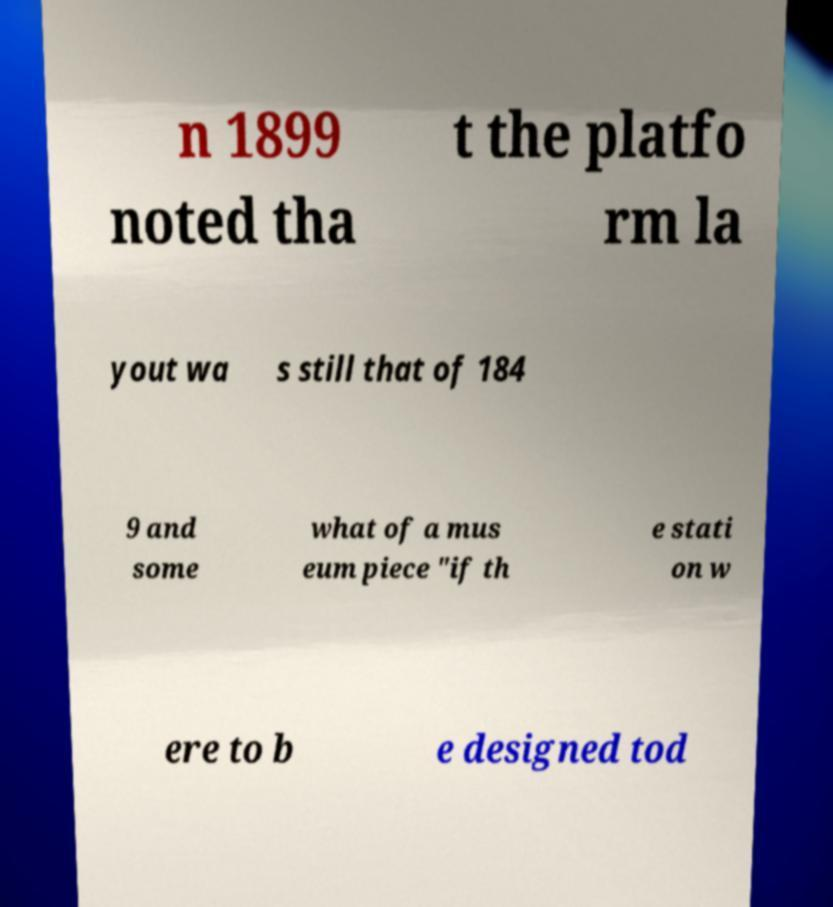For documentation purposes, I need the text within this image transcribed. Could you provide that? n 1899 noted tha t the platfo rm la yout wa s still that of 184 9 and some what of a mus eum piece "if th e stati on w ere to b e designed tod 